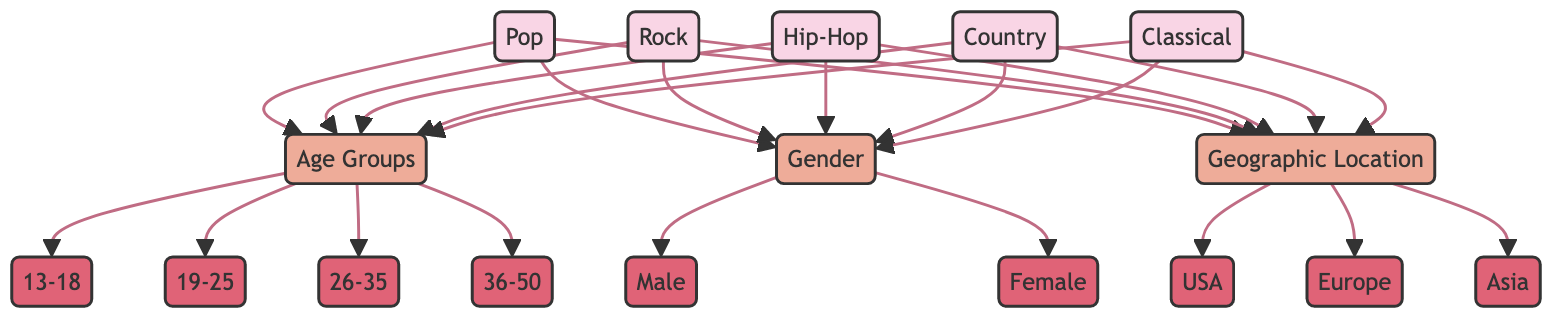What are the genres of music represented in the diagram? The diagram showcases five genres of music: Pop, Rock, Hip-Hop, Country, and Classical. These genres are visually distinguished at the top part of the diagram, connecting to the demographic categories below.
Answer: Pop, Rock, Hip-Hop, Country, Classical How many age groups are detailed in the diagram? The diagram segments listeners into four distinct age groups: 13-18, 19-25, 26-35, and 36-50. This information can be gleaned from the Age Groups node that links to these four categories.
Answer: Four Which demographic category branches out to more subcategories, Age Groups or Gender? The Age Groups category branches out to four subcategories (13-18, 19-25, 26-35, 36-50), whereas Gender branches out to only two (Male and Female). Thus, Age Groups has more connections.
Answer: Age Groups What genre is most likely to be popular among listeners aged 19-25? The diagram does not specify a single popular genre for a specific age group, but it indicates that each genre connects to every age group. Thus, any genre could be popular among listeners aged 19-25 without further data.
Answer: Any genre could be popular What is the connection between the demographic factor 'Gender' and the geographic location 'USA'? The connection is indirect; both Gender and Geographic Location are connected to every music genre. This means that, for instance, Male listeners in the USA may prefer any genre shown in the diagram, but no explicit relationship is defined. This illustrates the overlapping nature of these demographics across genres.
Answer: No explicit connection Which geographic location is linked the same number of times as the genre 'Rock'? Each geographic location (USA, Europe, Asia) connects to all five genres, including Rock. Therefore, all geographic locations are linked the same number of times as Rock.
Answer: USA, Europe, Asia 